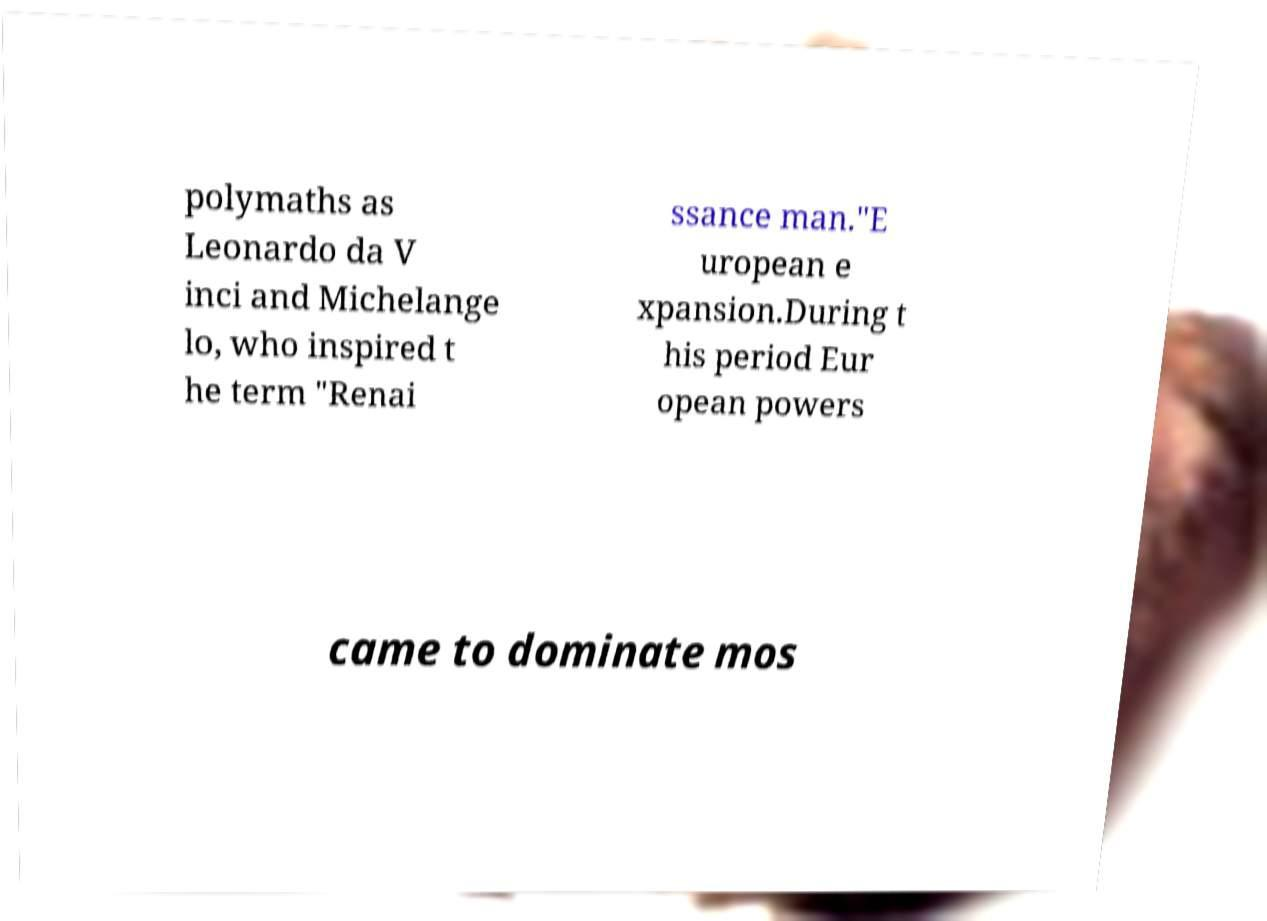Please identify and transcribe the text found in this image. polymaths as Leonardo da V inci and Michelange lo, who inspired t he term "Renai ssance man."E uropean e xpansion.During t his period Eur opean powers came to dominate mos 